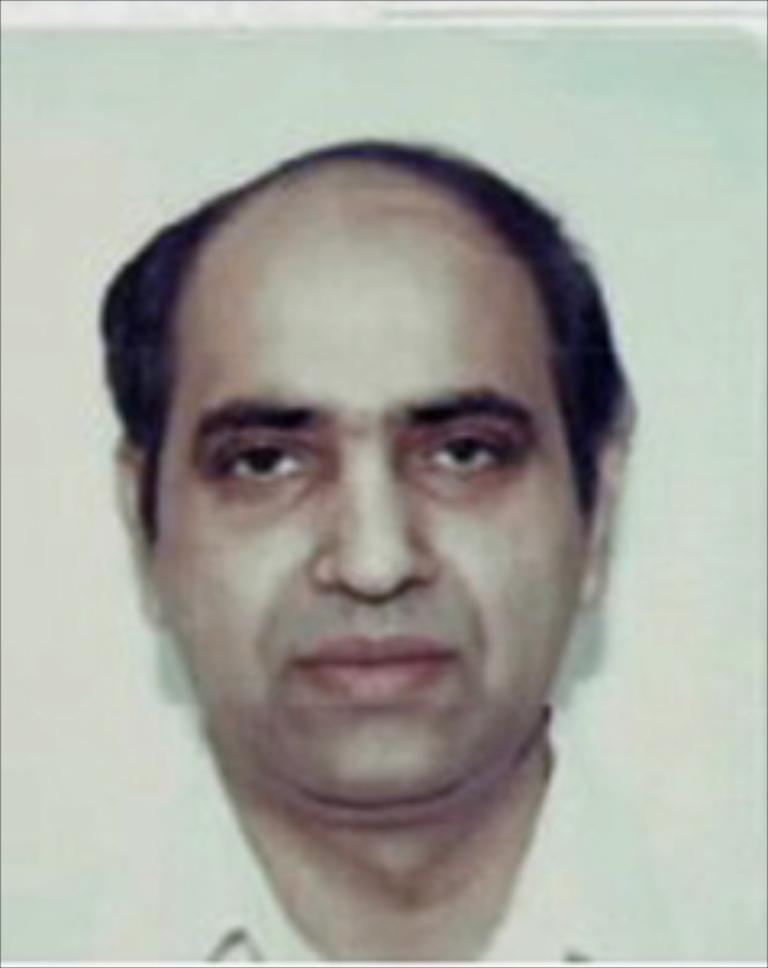Who is in the image? There is a man in the image. What is the man wearing in the image? The man is wearing a white shirt in the image. What color is the background of the image? The background of the image is white. What type of image might this be? The image might be a passport size photo. What type of ink is used to draw the man in the image? The image is a photograph, not a drawing, so there is no ink used. 